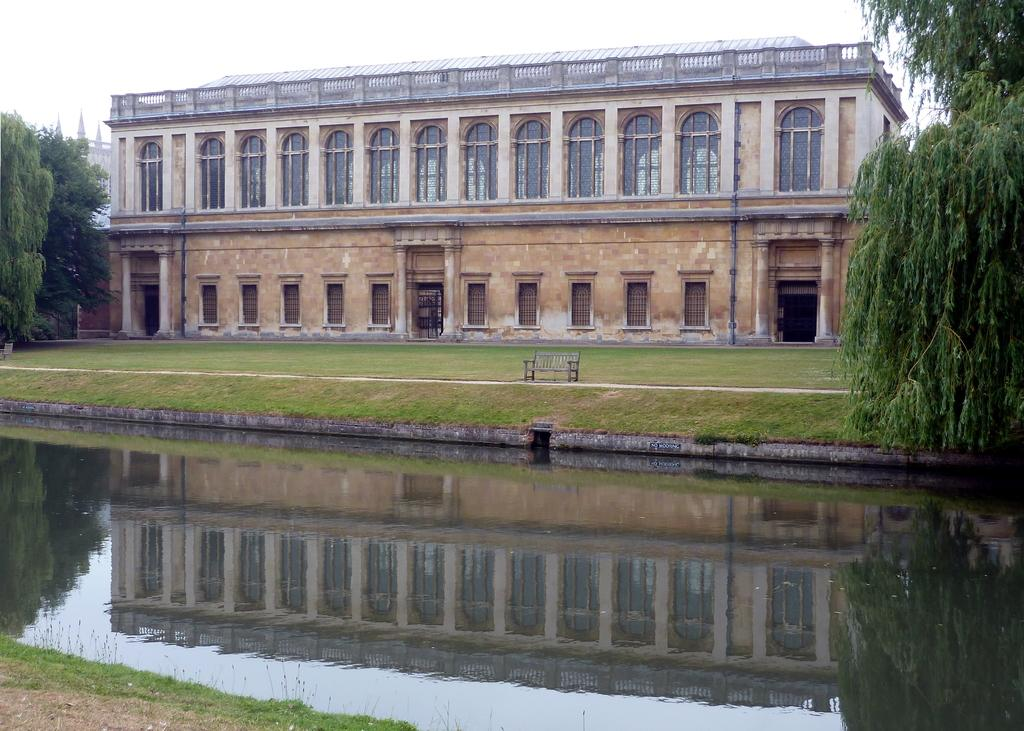What type of seating is visible in the image? There is a bench in the image. Where is the bench located? The bench is on a path. What can be seen in front of the bench? There is water in front of the bench. What is visible behind the bench? There are buildings and trees behind the bench. What is visible in the background of the image? The sky is visible in the background of the image. What type of fowl can be seen swimming in the water in front of the bench? There is no fowl visible in the image; only water is present in front of the bench. How many ducks are sitting on the bench in the image? There are no ducks present in the image; only a bench is visible. 